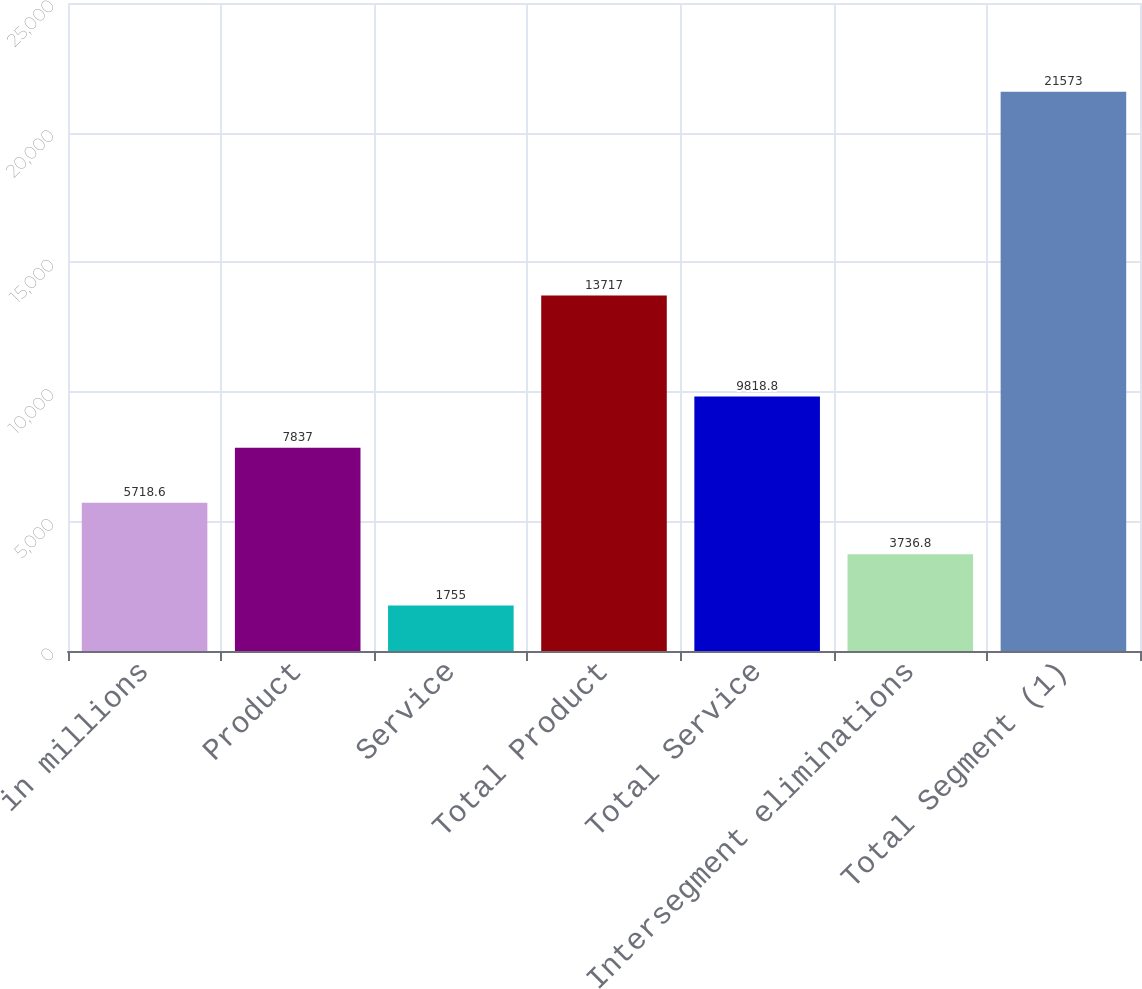Convert chart to OTSL. <chart><loc_0><loc_0><loc_500><loc_500><bar_chart><fcel>in millions<fcel>Product<fcel>Service<fcel>Total Product<fcel>Total Service<fcel>Intersegment eliminations<fcel>Total Segment (1)<nl><fcel>5718.6<fcel>7837<fcel>1755<fcel>13717<fcel>9818.8<fcel>3736.8<fcel>21573<nl></chart> 